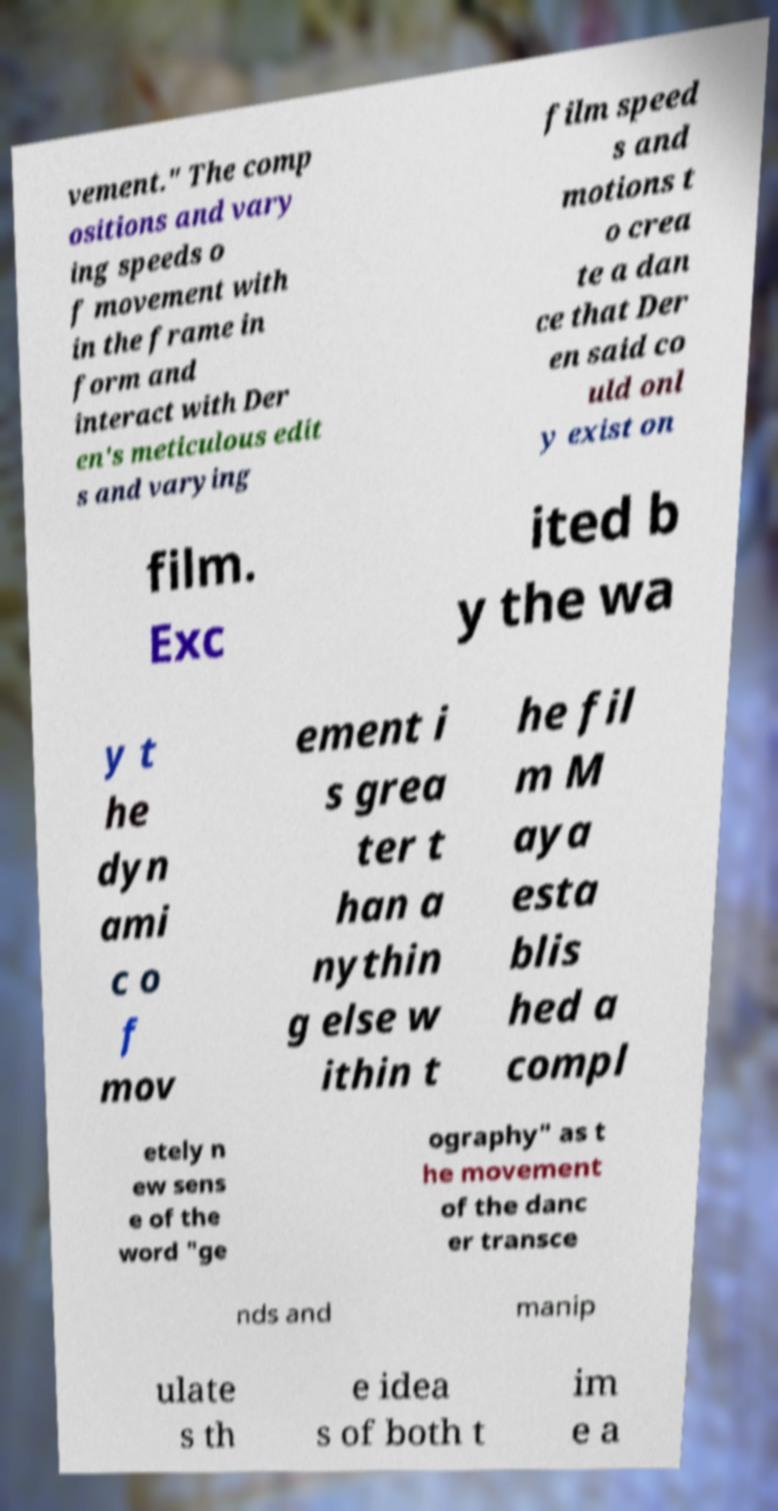For documentation purposes, I need the text within this image transcribed. Could you provide that? vement." The comp ositions and vary ing speeds o f movement with in the frame in form and interact with Der en's meticulous edit s and varying film speed s and motions t o crea te a dan ce that Der en said co uld onl y exist on film. Exc ited b y the wa y t he dyn ami c o f mov ement i s grea ter t han a nythin g else w ithin t he fil m M aya esta blis hed a compl etely n ew sens e of the word "ge ography" as t he movement of the danc er transce nds and manip ulate s th e idea s of both t im e a 